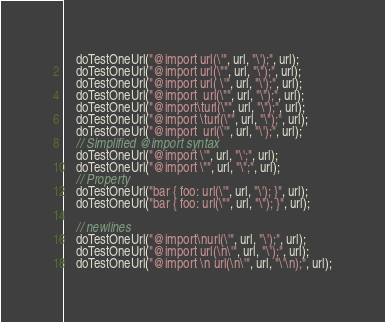Convert code to text. <code><loc_0><loc_0><loc_500><loc_500><_Java_>    doTestOneUrl("@import url(\'", url, "\');", url);
    doTestOneUrl("@import url(\"", url, "\");", url);
    doTestOneUrl("@import url( \'", url, "\');", url);
    doTestOneUrl("@import  url(\"", url, "\");", url);
    doTestOneUrl("@import\turl(\"", url, "\");", url);
    doTestOneUrl("@import \turl(\"", url, "\");", url);
    doTestOneUrl("@import  url(\'", url, "\');", url);
    // Simplified @import syntax
    doTestOneUrl("@import \'", url, "\';", url);
    doTestOneUrl("@import \"", url, "\";", url);
    // Property
    doTestOneUrl("bar { foo: url(\'", url, "\'); }", url);
    doTestOneUrl("bar { foo: url(\"", url, "\"); }", url);

    // newlines
    doTestOneUrl("@import\nurl(\'", url, "\');", url);
    doTestOneUrl("@import url(\n\'", url, "\');", url);
    doTestOneUrl("@import \n url(\n\'", url, "\'\n);", url);</code> 